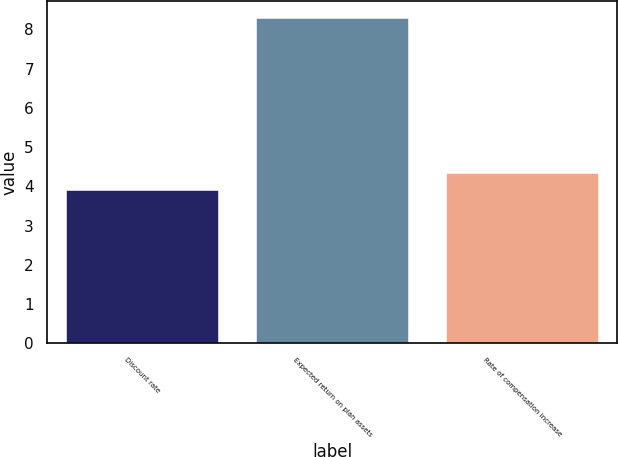Convert chart. <chart><loc_0><loc_0><loc_500><loc_500><bar_chart><fcel>Discount rate<fcel>Expected return on plan assets<fcel>Rate of compensation increase<nl><fcel>3.9<fcel>8.3<fcel>4.34<nl></chart> 